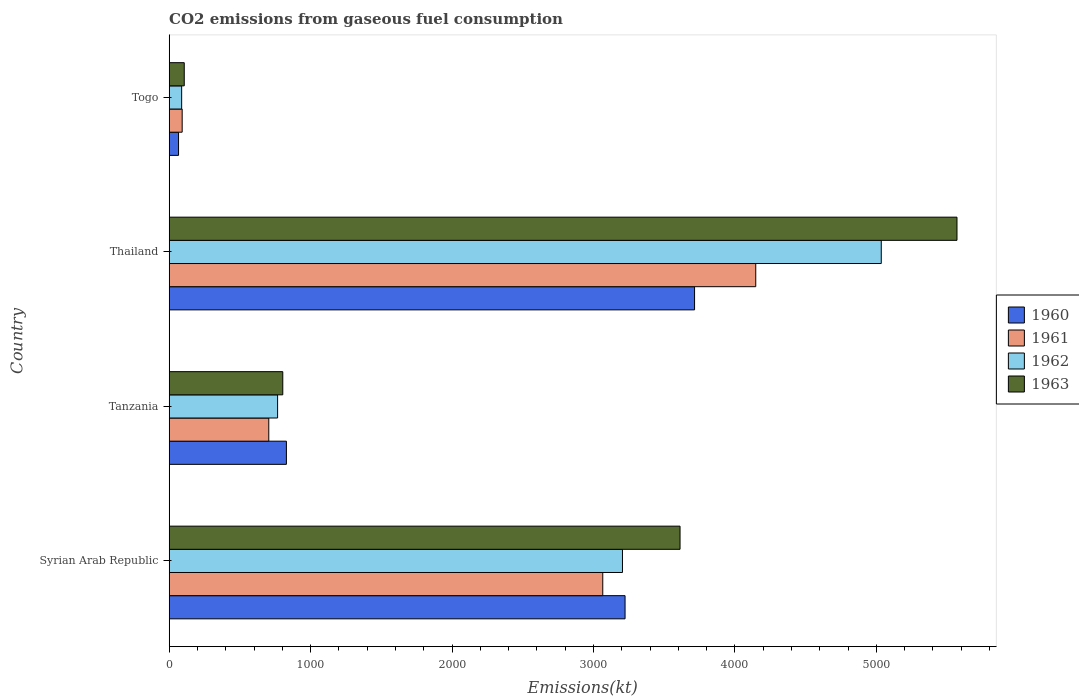How many different coloured bars are there?
Offer a terse response. 4. How many bars are there on the 1st tick from the top?
Offer a very short reply. 4. What is the label of the 2nd group of bars from the top?
Your answer should be very brief. Thailand. What is the amount of CO2 emitted in 1960 in Tanzania?
Offer a terse response. 828.74. Across all countries, what is the maximum amount of CO2 emitted in 1962?
Ensure brevity in your answer.  5034.79. Across all countries, what is the minimum amount of CO2 emitted in 1961?
Ensure brevity in your answer.  91.67. In which country was the amount of CO2 emitted in 1961 maximum?
Offer a terse response. Thailand. In which country was the amount of CO2 emitted in 1961 minimum?
Ensure brevity in your answer.  Togo. What is the total amount of CO2 emitted in 1961 in the graph?
Give a very brief answer. 8008.73. What is the difference between the amount of CO2 emitted in 1960 in Thailand and that in Togo?
Provide a short and direct response. 3648.66. What is the difference between the amount of CO2 emitted in 1963 in Togo and the amount of CO2 emitted in 1960 in Thailand?
Provide a short and direct response. -3608.33. What is the average amount of CO2 emitted in 1963 per country?
Make the answer very short. 2522.9. What is the difference between the amount of CO2 emitted in 1963 and amount of CO2 emitted in 1961 in Syrian Arab Republic?
Keep it short and to the point. 546.38. In how many countries, is the amount of CO2 emitted in 1961 greater than 1600 kt?
Make the answer very short. 2. What is the ratio of the amount of CO2 emitted in 1960 in Syrian Arab Republic to that in Togo?
Provide a succinct answer. 48.83. Is the difference between the amount of CO2 emitted in 1963 in Thailand and Togo greater than the difference between the amount of CO2 emitted in 1961 in Thailand and Togo?
Your response must be concise. Yes. What is the difference between the highest and the second highest amount of CO2 emitted in 1961?
Your answer should be compact. 1081.77. What is the difference between the highest and the lowest amount of CO2 emitted in 1963?
Your response must be concise. 5463.83. Is the sum of the amount of CO2 emitted in 1961 in Tanzania and Thailand greater than the maximum amount of CO2 emitted in 1963 across all countries?
Offer a very short reply. No. Is it the case that in every country, the sum of the amount of CO2 emitted in 1963 and amount of CO2 emitted in 1961 is greater than the sum of amount of CO2 emitted in 1960 and amount of CO2 emitted in 1962?
Keep it short and to the point. No. Are all the bars in the graph horizontal?
Your response must be concise. Yes. How many countries are there in the graph?
Offer a very short reply. 4. Does the graph contain any zero values?
Offer a terse response. No. How many legend labels are there?
Give a very brief answer. 4. How are the legend labels stacked?
Keep it short and to the point. Vertical. What is the title of the graph?
Keep it short and to the point. CO2 emissions from gaseous fuel consumption. What is the label or title of the X-axis?
Keep it short and to the point. Emissions(kt). What is the Emissions(kt) of 1960 in Syrian Arab Republic?
Make the answer very short. 3223.29. What is the Emissions(kt) in 1961 in Syrian Arab Republic?
Offer a terse response. 3065.61. What is the Emissions(kt) in 1962 in Syrian Arab Republic?
Offer a very short reply. 3204.96. What is the Emissions(kt) in 1963 in Syrian Arab Republic?
Make the answer very short. 3611.99. What is the Emissions(kt) in 1960 in Tanzania?
Your answer should be very brief. 828.74. What is the Emissions(kt) in 1961 in Tanzania?
Offer a terse response. 704.06. What is the Emissions(kt) in 1962 in Tanzania?
Provide a succinct answer. 766.4. What is the Emissions(kt) in 1963 in Tanzania?
Ensure brevity in your answer.  803.07. What is the Emissions(kt) of 1960 in Thailand?
Offer a terse response. 3714.67. What is the Emissions(kt) of 1961 in Thailand?
Keep it short and to the point. 4147.38. What is the Emissions(kt) of 1962 in Thailand?
Ensure brevity in your answer.  5034.79. What is the Emissions(kt) in 1963 in Thailand?
Ensure brevity in your answer.  5570.17. What is the Emissions(kt) in 1960 in Togo?
Keep it short and to the point. 66.01. What is the Emissions(kt) in 1961 in Togo?
Provide a short and direct response. 91.67. What is the Emissions(kt) in 1962 in Togo?
Make the answer very short. 88.01. What is the Emissions(kt) in 1963 in Togo?
Your answer should be very brief. 106.34. Across all countries, what is the maximum Emissions(kt) in 1960?
Keep it short and to the point. 3714.67. Across all countries, what is the maximum Emissions(kt) of 1961?
Provide a short and direct response. 4147.38. Across all countries, what is the maximum Emissions(kt) in 1962?
Offer a very short reply. 5034.79. Across all countries, what is the maximum Emissions(kt) of 1963?
Offer a very short reply. 5570.17. Across all countries, what is the minimum Emissions(kt) of 1960?
Ensure brevity in your answer.  66.01. Across all countries, what is the minimum Emissions(kt) of 1961?
Offer a terse response. 91.67. Across all countries, what is the minimum Emissions(kt) in 1962?
Provide a succinct answer. 88.01. Across all countries, what is the minimum Emissions(kt) of 1963?
Make the answer very short. 106.34. What is the total Emissions(kt) of 1960 in the graph?
Provide a short and direct response. 7832.71. What is the total Emissions(kt) in 1961 in the graph?
Offer a very short reply. 8008.73. What is the total Emissions(kt) in 1962 in the graph?
Provide a succinct answer. 9094.16. What is the total Emissions(kt) of 1963 in the graph?
Your answer should be compact. 1.01e+04. What is the difference between the Emissions(kt) in 1960 in Syrian Arab Republic and that in Tanzania?
Your response must be concise. 2394.55. What is the difference between the Emissions(kt) in 1961 in Syrian Arab Republic and that in Tanzania?
Your response must be concise. 2361.55. What is the difference between the Emissions(kt) in 1962 in Syrian Arab Republic and that in Tanzania?
Provide a short and direct response. 2438.55. What is the difference between the Emissions(kt) of 1963 in Syrian Arab Republic and that in Tanzania?
Keep it short and to the point. 2808.92. What is the difference between the Emissions(kt) in 1960 in Syrian Arab Republic and that in Thailand?
Provide a succinct answer. -491.38. What is the difference between the Emissions(kt) of 1961 in Syrian Arab Republic and that in Thailand?
Provide a short and direct response. -1081.77. What is the difference between the Emissions(kt) of 1962 in Syrian Arab Republic and that in Thailand?
Your answer should be compact. -1829.83. What is the difference between the Emissions(kt) in 1963 in Syrian Arab Republic and that in Thailand?
Offer a terse response. -1958.18. What is the difference between the Emissions(kt) in 1960 in Syrian Arab Republic and that in Togo?
Your response must be concise. 3157.29. What is the difference between the Emissions(kt) of 1961 in Syrian Arab Republic and that in Togo?
Offer a terse response. 2973.94. What is the difference between the Emissions(kt) in 1962 in Syrian Arab Republic and that in Togo?
Keep it short and to the point. 3116.95. What is the difference between the Emissions(kt) in 1963 in Syrian Arab Republic and that in Togo?
Keep it short and to the point. 3505.65. What is the difference between the Emissions(kt) of 1960 in Tanzania and that in Thailand?
Provide a short and direct response. -2885.93. What is the difference between the Emissions(kt) in 1961 in Tanzania and that in Thailand?
Provide a succinct answer. -3443.31. What is the difference between the Emissions(kt) in 1962 in Tanzania and that in Thailand?
Offer a terse response. -4268.39. What is the difference between the Emissions(kt) in 1963 in Tanzania and that in Thailand?
Provide a succinct answer. -4767.1. What is the difference between the Emissions(kt) in 1960 in Tanzania and that in Togo?
Keep it short and to the point. 762.74. What is the difference between the Emissions(kt) of 1961 in Tanzania and that in Togo?
Make the answer very short. 612.39. What is the difference between the Emissions(kt) in 1962 in Tanzania and that in Togo?
Provide a succinct answer. 678.39. What is the difference between the Emissions(kt) of 1963 in Tanzania and that in Togo?
Offer a very short reply. 696.73. What is the difference between the Emissions(kt) of 1960 in Thailand and that in Togo?
Your response must be concise. 3648.66. What is the difference between the Emissions(kt) in 1961 in Thailand and that in Togo?
Offer a terse response. 4055.7. What is the difference between the Emissions(kt) of 1962 in Thailand and that in Togo?
Provide a succinct answer. 4946.78. What is the difference between the Emissions(kt) in 1963 in Thailand and that in Togo?
Your response must be concise. 5463.83. What is the difference between the Emissions(kt) of 1960 in Syrian Arab Republic and the Emissions(kt) of 1961 in Tanzania?
Your answer should be very brief. 2519.23. What is the difference between the Emissions(kt) in 1960 in Syrian Arab Republic and the Emissions(kt) in 1962 in Tanzania?
Make the answer very short. 2456.89. What is the difference between the Emissions(kt) of 1960 in Syrian Arab Republic and the Emissions(kt) of 1963 in Tanzania?
Give a very brief answer. 2420.22. What is the difference between the Emissions(kt) of 1961 in Syrian Arab Republic and the Emissions(kt) of 1962 in Tanzania?
Offer a terse response. 2299.21. What is the difference between the Emissions(kt) of 1961 in Syrian Arab Republic and the Emissions(kt) of 1963 in Tanzania?
Keep it short and to the point. 2262.54. What is the difference between the Emissions(kt) of 1962 in Syrian Arab Republic and the Emissions(kt) of 1963 in Tanzania?
Your response must be concise. 2401.89. What is the difference between the Emissions(kt) in 1960 in Syrian Arab Republic and the Emissions(kt) in 1961 in Thailand?
Give a very brief answer. -924.08. What is the difference between the Emissions(kt) in 1960 in Syrian Arab Republic and the Emissions(kt) in 1962 in Thailand?
Ensure brevity in your answer.  -1811.5. What is the difference between the Emissions(kt) of 1960 in Syrian Arab Republic and the Emissions(kt) of 1963 in Thailand?
Offer a terse response. -2346.88. What is the difference between the Emissions(kt) in 1961 in Syrian Arab Republic and the Emissions(kt) in 1962 in Thailand?
Your answer should be very brief. -1969.18. What is the difference between the Emissions(kt) of 1961 in Syrian Arab Republic and the Emissions(kt) of 1963 in Thailand?
Give a very brief answer. -2504.56. What is the difference between the Emissions(kt) in 1962 in Syrian Arab Republic and the Emissions(kt) in 1963 in Thailand?
Provide a short and direct response. -2365.22. What is the difference between the Emissions(kt) of 1960 in Syrian Arab Republic and the Emissions(kt) of 1961 in Togo?
Provide a short and direct response. 3131.62. What is the difference between the Emissions(kt) of 1960 in Syrian Arab Republic and the Emissions(kt) of 1962 in Togo?
Make the answer very short. 3135.28. What is the difference between the Emissions(kt) in 1960 in Syrian Arab Republic and the Emissions(kt) in 1963 in Togo?
Ensure brevity in your answer.  3116.95. What is the difference between the Emissions(kt) in 1961 in Syrian Arab Republic and the Emissions(kt) in 1962 in Togo?
Make the answer very short. 2977.6. What is the difference between the Emissions(kt) of 1961 in Syrian Arab Republic and the Emissions(kt) of 1963 in Togo?
Provide a succinct answer. 2959.27. What is the difference between the Emissions(kt) of 1962 in Syrian Arab Republic and the Emissions(kt) of 1963 in Togo?
Your response must be concise. 3098.61. What is the difference between the Emissions(kt) of 1960 in Tanzania and the Emissions(kt) of 1961 in Thailand?
Provide a succinct answer. -3318.64. What is the difference between the Emissions(kt) in 1960 in Tanzania and the Emissions(kt) in 1962 in Thailand?
Keep it short and to the point. -4206.05. What is the difference between the Emissions(kt) in 1960 in Tanzania and the Emissions(kt) in 1963 in Thailand?
Provide a succinct answer. -4741.43. What is the difference between the Emissions(kt) of 1961 in Tanzania and the Emissions(kt) of 1962 in Thailand?
Ensure brevity in your answer.  -4330.73. What is the difference between the Emissions(kt) in 1961 in Tanzania and the Emissions(kt) in 1963 in Thailand?
Give a very brief answer. -4866.11. What is the difference between the Emissions(kt) of 1962 in Tanzania and the Emissions(kt) of 1963 in Thailand?
Provide a short and direct response. -4803.77. What is the difference between the Emissions(kt) of 1960 in Tanzania and the Emissions(kt) of 1961 in Togo?
Give a very brief answer. 737.07. What is the difference between the Emissions(kt) in 1960 in Tanzania and the Emissions(kt) in 1962 in Togo?
Make the answer very short. 740.73. What is the difference between the Emissions(kt) of 1960 in Tanzania and the Emissions(kt) of 1963 in Togo?
Give a very brief answer. 722.4. What is the difference between the Emissions(kt) in 1961 in Tanzania and the Emissions(kt) in 1962 in Togo?
Provide a short and direct response. 616.06. What is the difference between the Emissions(kt) in 1961 in Tanzania and the Emissions(kt) in 1963 in Togo?
Your response must be concise. 597.72. What is the difference between the Emissions(kt) in 1962 in Tanzania and the Emissions(kt) in 1963 in Togo?
Offer a very short reply. 660.06. What is the difference between the Emissions(kt) in 1960 in Thailand and the Emissions(kt) in 1961 in Togo?
Your answer should be very brief. 3623. What is the difference between the Emissions(kt) of 1960 in Thailand and the Emissions(kt) of 1962 in Togo?
Provide a succinct answer. 3626.66. What is the difference between the Emissions(kt) in 1960 in Thailand and the Emissions(kt) in 1963 in Togo?
Give a very brief answer. 3608.33. What is the difference between the Emissions(kt) in 1961 in Thailand and the Emissions(kt) in 1962 in Togo?
Give a very brief answer. 4059.37. What is the difference between the Emissions(kt) of 1961 in Thailand and the Emissions(kt) of 1963 in Togo?
Provide a short and direct response. 4041.03. What is the difference between the Emissions(kt) in 1962 in Thailand and the Emissions(kt) in 1963 in Togo?
Offer a very short reply. 4928.45. What is the average Emissions(kt) of 1960 per country?
Your response must be concise. 1958.18. What is the average Emissions(kt) in 1961 per country?
Provide a short and direct response. 2002.18. What is the average Emissions(kt) of 1962 per country?
Make the answer very short. 2273.54. What is the average Emissions(kt) of 1963 per country?
Make the answer very short. 2522.9. What is the difference between the Emissions(kt) of 1960 and Emissions(kt) of 1961 in Syrian Arab Republic?
Offer a terse response. 157.68. What is the difference between the Emissions(kt) in 1960 and Emissions(kt) in 1962 in Syrian Arab Republic?
Your answer should be very brief. 18.34. What is the difference between the Emissions(kt) of 1960 and Emissions(kt) of 1963 in Syrian Arab Republic?
Offer a terse response. -388.7. What is the difference between the Emissions(kt) in 1961 and Emissions(kt) in 1962 in Syrian Arab Republic?
Your response must be concise. -139.35. What is the difference between the Emissions(kt) in 1961 and Emissions(kt) in 1963 in Syrian Arab Republic?
Keep it short and to the point. -546.38. What is the difference between the Emissions(kt) in 1962 and Emissions(kt) in 1963 in Syrian Arab Republic?
Provide a succinct answer. -407.04. What is the difference between the Emissions(kt) in 1960 and Emissions(kt) in 1961 in Tanzania?
Keep it short and to the point. 124.68. What is the difference between the Emissions(kt) of 1960 and Emissions(kt) of 1962 in Tanzania?
Offer a very short reply. 62.34. What is the difference between the Emissions(kt) in 1960 and Emissions(kt) in 1963 in Tanzania?
Provide a short and direct response. 25.67. What is the difference between the Emissions(kt) in 1961 and Emissions(kt) in 1962 in Tanzania?
Keep it short and to the point. -62.34. What is the difference between the Emissions(kt) of 1961 and Emissions(kt) of 1963 in Tanzania?
Your answer should be compact. -99.01. What is the difference between the Emissions(kt) of 1962 and Emissions(kt) of 1963 in Tanzania?
Keep it short and to the point. -36.67. What is the difference between the Emissions(kt) of 1960 and Emissions(kt) of 1961 in Thailand?
Your answer should be very brief. -432.71. What is the difference between the Emissions(kt) of 1960 and Emissions(kt) of 1962 in Thailand?
Your answer should be very brief. -1320.12. What is the difference between the Emissions(kt) in 1960 and Emissions(kt) in 1963 in Thailand?
Keep it short and to the point. -1855.5. What is the difference between the Emissions(kt) of 1961 and Emissions(kt) of 1962 in Thailand?
Make the answer very short. -887.41. What is the difference between the Emissions(kt) in 1961 and Emissions(kt) in 1963 in Thailand?
Provide a succinct answer. -1422.8. What is the difference between the Emissions(kt) in 1962 and Emissions(kt) in 1963 in Thailand?
Make the answer very short. -535.38. What is the difference between the Emissions(kt) in 1960 and Emissions(kt) in 1961 in Togo?
Offer a terse response. -25.67. What is the difference between the Emissions(kt) of 1960 and Emissions(kt) of 1962 in Togo?
Offer a very short reply. -22. What is the difference between the Emissions(kt) of 1960 and Emissions(kt) of 1963 in Togo?
Your response must be concise. -40.34. What is the difference between the Emissions(kt) of 1961 and Emissions(kt) of 1962 in Togo?
Give a very brief answer. 3.67. What is the difference between the Emissions(kt) in 1961 and Emissions(kt) in 1963 in Togo?
Provide a succinct answer. -14.67. What is the difference between the Emissions(kt) in 1962 and Emissions(kt) in 1963 in Togo?
Offer a very short reply. -18.34. What is the ratio of the Emissions(kt) of 1960 in Syrian Arab Republic to that in Tanzania?
Provide a succinct answer. 3.89. What is the ratio of the Emissions(kt) of 1961 in Syrian Arab Republic to that in Tanzania?
Ensure brevity in your answer.  4.35. What is the ratio of the Emissions(kt) of 1962 in Syrian Arab Republic to that in Tanzania?
Provide a succinct answer. 4.18. What is the ratio of the Emissions(kt) in 1963 in Syrian Arab Republic to that in Tanzania?
Offer a terse response. 4.5. What is the ratio of the Emissions(kt) of 1960 in Syrian Arab Republic to that in Thailand?
Offer a terse response. 0.87. What is the ratio of the Emissions(kt) of 1961 in Syrian Arab Republic to that in Thailand?
Offer a terse response. 0.74. What is the ratio of the Emissions(kt) of 1962 in Syrian Arab Republic to that in Thailand?
Give a very brief answer. 0.64. What is the ratio of the Emissions(kt) in 1963 in Syrian Arab Republic to that in Thailand?
Provide a succinct answer. 0.65. What is the ratio of the Emissions(kt) of 1960 in Syrian Arab Republic to that in Togo?
Make the answer very short. 48.83. What is the ratio of the Emissions(kt) in 1961 in Syrian Arab Republic to that in Togo?
Provide a succinct answer. 33.44. What is the ratio of the Emissions(kt) of 1962 in Syrian Arab Republic to that in Togo?
Your answer should be very brief. 36.42. What is the ratio of the Emissions(kt) of 1963 in Syrian Arab Republic to that in Togo?
Your answer should be compact. 33.97. What is the ratio of the Emissions(kt) of 1960 in Tanzania to that in Thailand?
Your answer should be compact. 0.22. What is the ratio of the Emissions(kt) of 1961 in Tanzania to that in Thailand?
Make the answer very short. 0.17. What is the ratio of the Emissions(kt) in 1962 in Tanzania to that in Thailand?
Your answer should be compact. 0.15. What is the ratio of the Emissions(kt) of 1963 in Tanzania to that in Thailand?
Your answer should be very brief. 0.14. What is the ratio of the Emissions(kt) of 1960 in Tanzania to that in Togo?
Offer a very short reply. 12.56. What is the ratio of the Emissions(kt) of 1961 in Tanzania to that in Togo?
Ensure brevity in your answer.  7.68. What is the ratio of the Emissions(kt) of 1962 in Tanzania to that in Togo?
Keep it short and to the point. 8.71. What is the ratio of the Emissions(kt) of 1963 in Tanzania to that in Togo?
Your response must be concise. 7.55. What is the ratio of the Emissions(kt) of 1960 in Thailand to that in Togo?
Make the answer very short. 56.28. What is the ratio of the Emissions(kt) in 1961 in Thailand to that in Togo?
Make the answer very short. 45.24. What is the ratio of the Emissions(kt) of 1962 in Thailand to that in Togo?
Make the answer very short. 57.21. What is the ratio of the Emissions(kt) of 1963 in Thailand to that in Togo?
Offer a terse response. 52.38. What is the difference between the highest and the second highest Emissions(kt) of 1960?
Your answer should be compact. 491.38. What is the difference between the highest and the second highest Emissions(kt) of 1961?
Your response must be concise. 1081.77. What is the difference between the highest and the second highest Emissions(kt) of 1962?
Your response must be concise. 1829.83. What is the difference between the highest and the second highest Emissions(kt) of 1963?
Your response must be concise. 1958.18. What is the difference between the highest and the lowest Emissions(kt) of 1960?
Your response must be concise. 3648.66. What is the difference between the highest and the lowest Emissions(kt) of 1961?
Ensure brevity in your answer.  4055.7. What is the difference between the highest and the lowest Emissions(kt) of 1962?
Provide a short and direct response. 4946.78. What is the difference between the highest and the lowest Emissions(kt) of 1963?
Your answer should be very brief. 5463.83. 